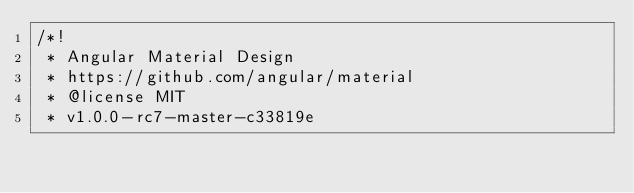<code> <loc_0><loc_0><loc_500><loc_500><_CSS_>/*!
 * Angular Material Design
 * https://github.com/angular/material
 * @license MIT
 * v1.0.0-rc7-master-c33819e</code> 